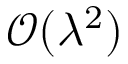Convert formula to latex. <formula><loc_0><loc_0><loc_500><loc_500>\mathcal { O } ( \lambda ^ { 2 } )</formula> 